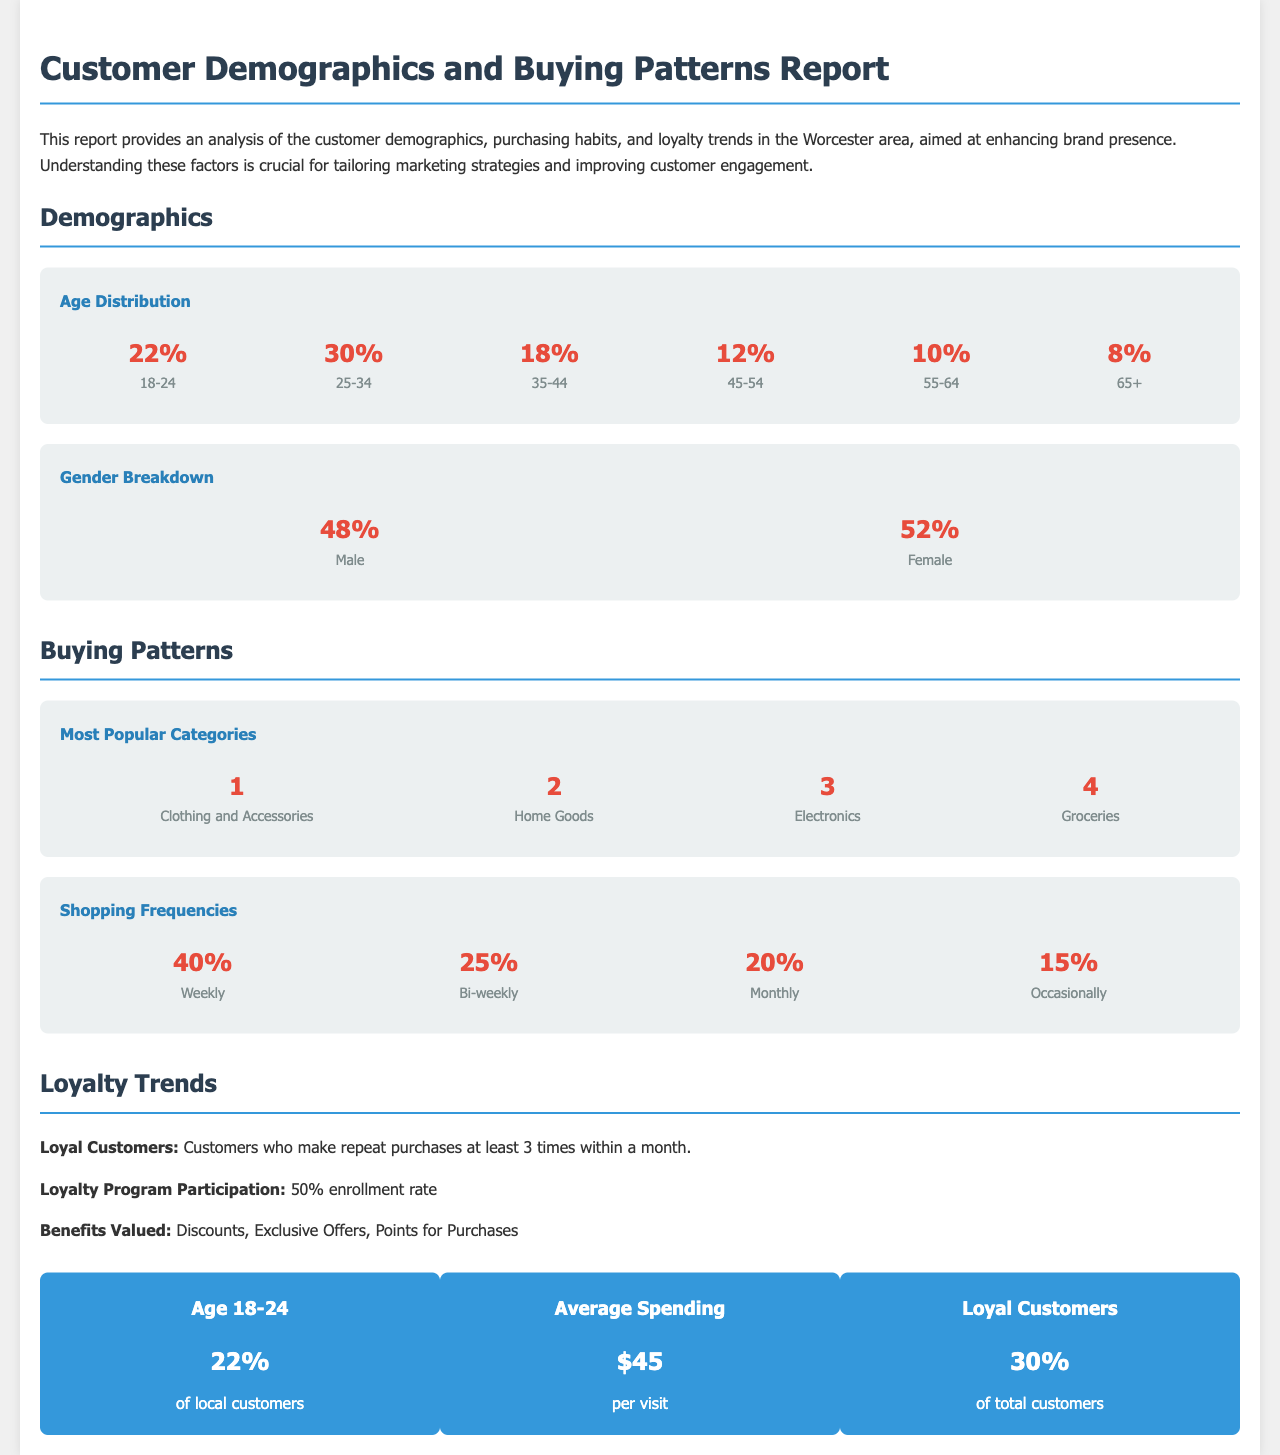What is the percentage of customers aged 18-24? The document states that 22% of local customers fall within the age range of 18-24.
Answer: 22% What is the gender breakdown of customers? According to the report, 48% are male and 52% are female.
Answer: 48% Male, 52% Female What is the most popular buying category? The report reveals that Clothing and Accessories is the number one category preferred by customers.
Answer: Clothing and Accessories What percentage of customers shop weekly? The document indicates that 40% of customers shop on a weekly basis.
Answer: 40% What is the average spending per visit? The report mentions that the average spending per visit is $45.
Answer: $45 What is the loyalty program participation rate? According to the document, the loyalty program has a 50% enrollment rate.
Answer: 50% What percentage of customers are considered loyal? The report states that 30% of total customers are identified as loyal customers.
Answer: 30% Which age group has the highest percentage? The document indicates that the 25-34 age group has the highest percentage at 30%.
Answer: 25-34 (30%) What is the percentage of customers aged 65 or older? The report shows that 8% of customers are aged 65 and older.
Answer: 8% 